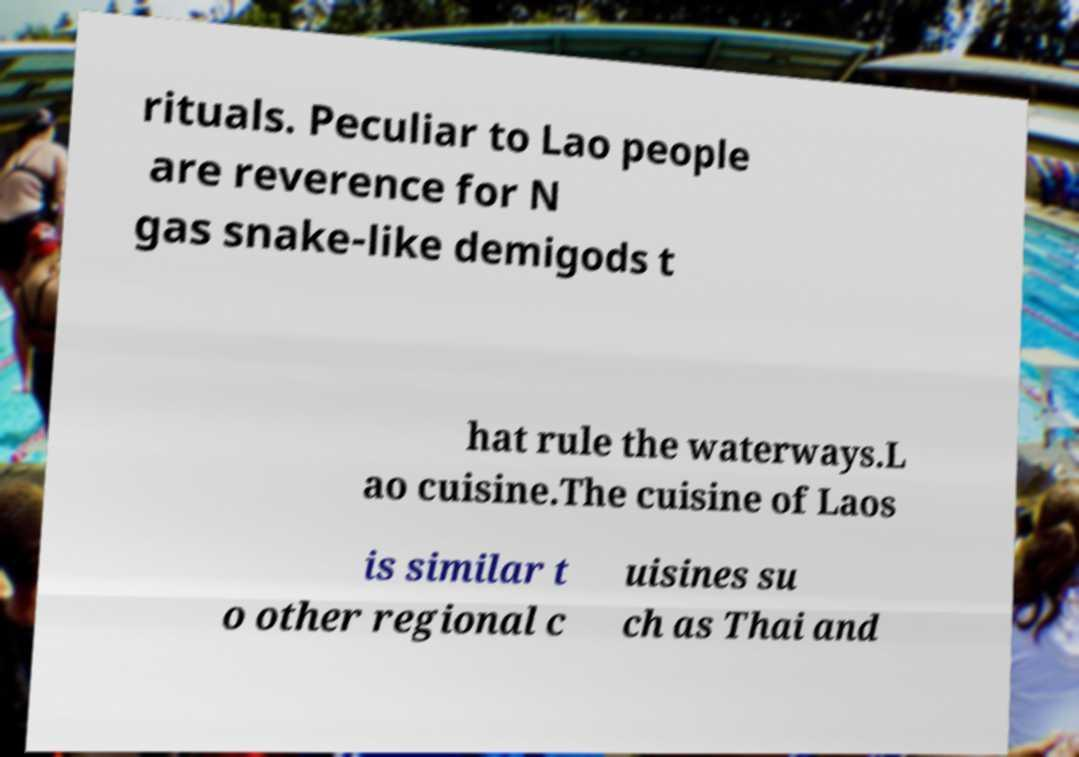Can you accurately transcribe the text from the provided image for me? rituals. Peculiar to Lao people are reverence for N gas snake-like demigods t hat rule the waterways.L ao cuisine.The cuisine of Laos is similar t o other regional c uisines su ch as Thai and 